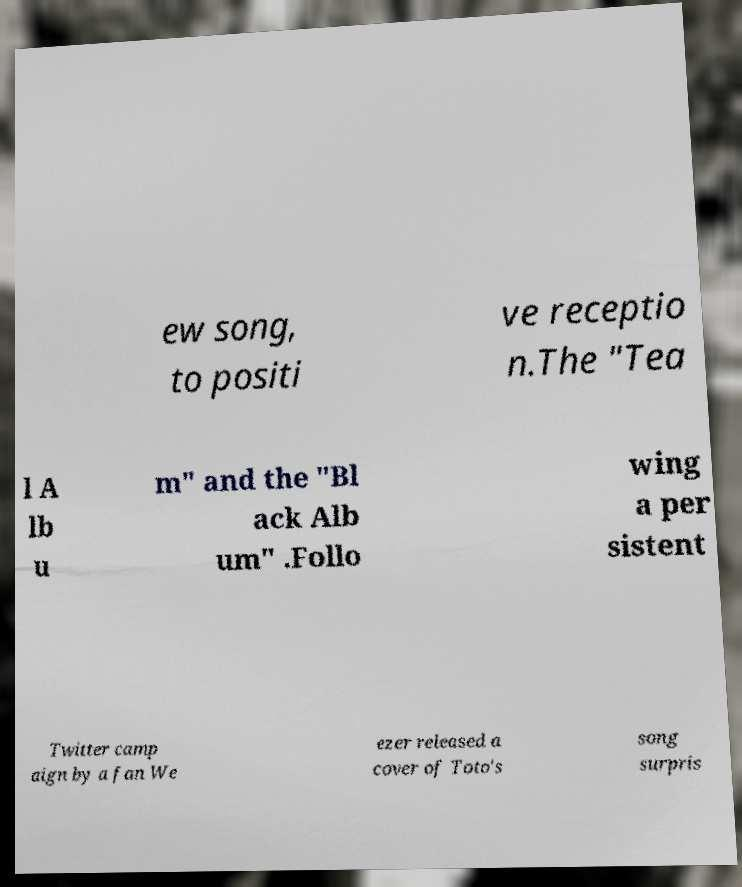Could you extract and type out the text from this image? ew song, to positi ve receptio n.The "Tea l A lb u m" and the "Bl ack Alb um" .Follo wing a per sistent Twitter camp aign by a fan We ezer released a cover of Toto's song surpris 